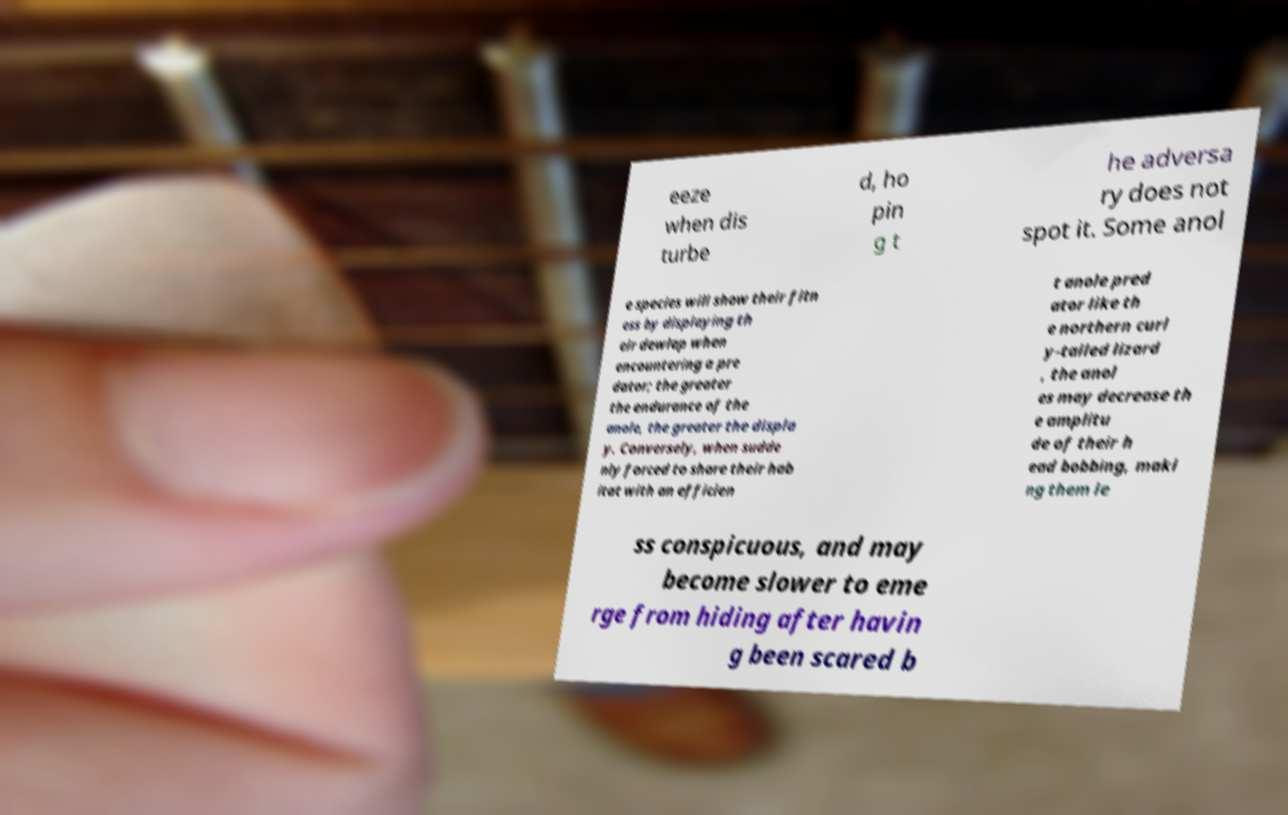Please identify and transcribe the text found in this image. eeze when dis turbe d, ho pin g t he adversa ry does not spot it. Some anol e species will show their fitn ess by displaying th eir dewlap when encountering a pre dator; the greater the endurance of the anole, the greater the displa y. Conversely, when sudde nly forced to share their hab itat with an efficien t anole pred ator like th e northern curl y-tailed lizard , the anol es may decrease th e amplitu de of their h ead bobbing, maki ng them le ss conspicuous, and may become slower to eme rge from hiding after havin g been scared b 